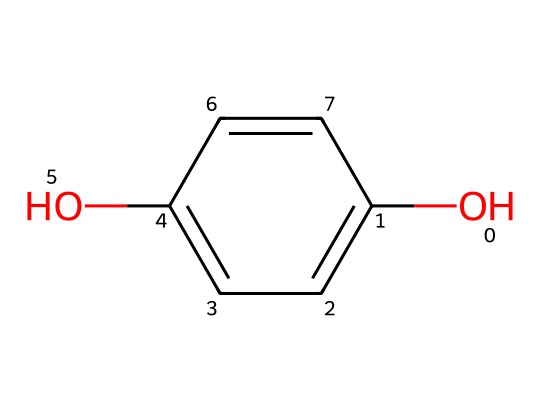How many carbon atoms are in the compound? Analyzing the SMILES notation, we can count the 'C' characters, which represent carbon atoms. The structure shows a total of 8 carbon atoms.
Answer: 8 What functional groups are present in this compound? By observing the structure, we see the presence of an -OH group (hydroxyl) due to "OC" and a carbon-carbon double bond (C=C) evident in the ring structure. Therefore, the functional groups are hydroxyl and alkene.
Answer: hydroxyl, alkene Is the compound aromatic? The presence of a cyclic structure with alternating double bonds signifies that this compound is aromatic due to the rule of conjugation within the ring.
Answer: Yes What is the degree of unsaturation in the molecule? The degree of unsaturation can be calculated based on the formula which relates to the number of rings and multiple bonds. In this case, the structure has two rings and three double bonds (one of which is part of the ring), leading to a degree of unsaturation of 4.
Answer: 4 Which type of bond connects the carbons in the ring? The SMILES structure indicates multiple double bonds (C=C) within the cyclic structure, which defines that the bonds connecting the carbons in the ring are double bonds.
Answer: double Does this compound have isomers? Given the number of carbon and functional groups, there are potential arrangements of these atoms that could lead to different isomers. A careful analysis of the structure indicates at least one positional isomer might exist.
Answer: Yes 